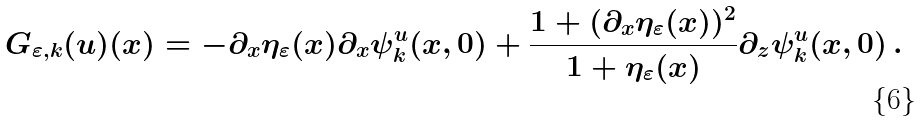<formula> <loc_0><loc_0><loc_500><loc_500>G _ { \varepsilon , k } ( u ) ( x ) = - \partial _ { x } \eta _ { \varepsilon } ( x ) \partial _ { x } \psi _ { k } ^ { u } ( x , 0 ) + \frac { 1 + ( \partial _ { x } \eta _ { \varepsilon } ( x ) ) ^ { 2 } } { 1 + \eta _ { \varepsilon } ( x ) } \partial _ { z } \psi _ { k } ^ { u } ( x , 0 ) \, .</formula> 